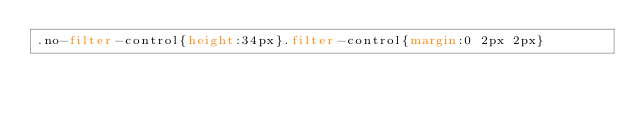<code> <loc_0><loc_0><loc_500><loc_500><_CSS_>.no-filter-control{height:34px}.filter-control{margin:0 2px 2px}</code> 